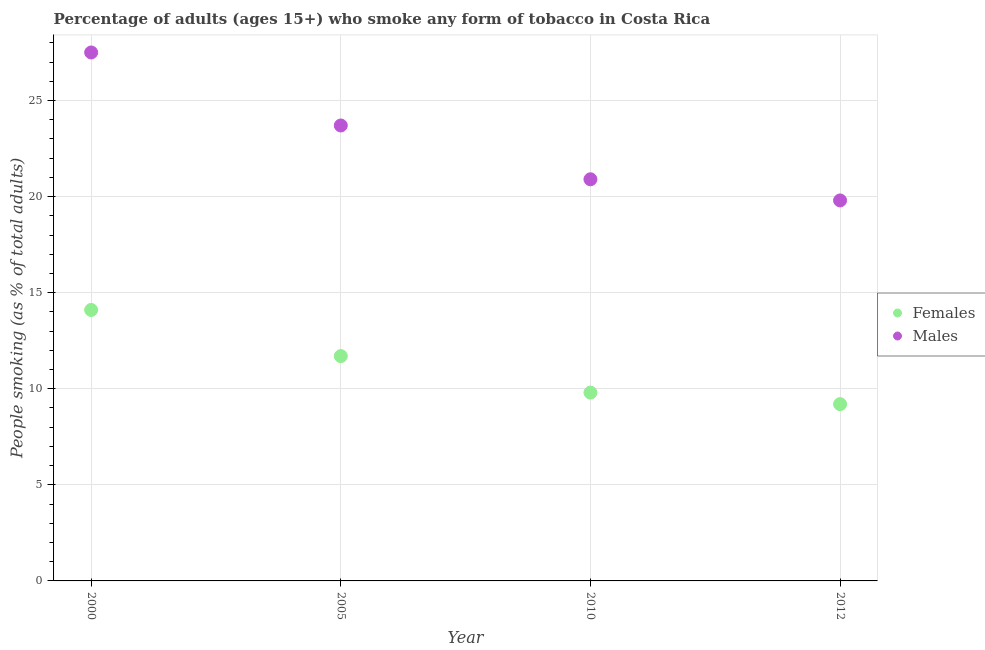How many different coloured dotlines are there?
Offer a terse response. 2. Is the number of dotlines equal to the number of legend labels?
Offer a terse response. Yes. What is the percentage of females who smoke in 2000?
Give a very brief answer. 14.1. Across all years, what is the maximum percentage of males who smoke?
Provide a short and direct response. 27.5. Across all years, what is the minimum percentage of females who smoke?
Your response must be concise. 9.2. In which year was the percentage of females who smoke maximum?
Give a very brief answer. 2000. What is the total percentage of males who smoke in the graph?
Your answer should be compact. 91.9. What is the difference between the percentage of females who smoke in 2005 and that in 2012?
Give a very brief answer. 2.5. In the year 2012, what is the difference between the percentage of males who smoke and percentage of females who smoke?
Keep it short and to the point. 10.6. What is the ratio of the percentage of females who smoke in 2005 to that in 2010?
Give a very brief answer. 1.19. What is the difference between the highest and the second highest percentage of males who smoke?
Give a very brief answer. 3.8. What is the difference between the highest and the lowest percentage of males who smoke?
Keep it short and to the point. 7.7. In how many years, is the percentage of females who smoke greater than the average percentage of females who smoke taken over all years?
Provide a succinct answer. 2. Is the sum of the percentage of males who smoke in 2010 and 2012 greater than the maximum percentage of females who smoke across all years?
Ensure brevity in your answer.  Yes. Does the percentage of females who smoke monotonically increase over the years?
Ensure brevity in your answer.  No. How many dotlines are there?
Keep it short and to the point. 2. How many years are there in the graph?
Your answer should be compact. 4. Are the values on the major ticks of Y-axis written in scientific E-notation?
Ensure brevity in your answer.  No. Does the graph contain any zero values?
Give a very brief answer. No. What is the title of the graph?
Keep it short and to the point. Percentage of adults (ages 15+) who smoke any form of tobacco in Costa Rica. What is the label or title of the X-axis?
Make the answer very short. Year. What is the label or title of the Y-axis?
Offer a very short reply. People smoking (as % of total adults). What is the People smoking (as % of total adults) of Males in 2000?
Your answer should be very brief. 27.5. What is the People smoking (as % of total adults) in Males in 2005?
Your answer should be compact. 23.7. What is the People smoking (as % of total adults) in Males in 2010?
Offer a very short reply. 20.9. What is the People smoking (as % of total adults) in Females in 2012?
Provide a succinct answer. 9.2. What is the People smoking (as % of total adults) of Males in 2012?
Keep it short and to the point. 19.8. Across all years, what is the maximum People smoking (as % of total adults) in Females?
Your response must be concise. 14.1. Across all years, what is the minimum People smoking (as % of total adults) in Females?
Your answer should be very brief. 9.2. Across all years, what is the minimum People smoking (as % of total adults) in Males?
Give a very brief answer. 19.8. What is the total People smoking (as % of total adults) in Females in the graph?
Offer a very short reply. 44.8. What is the total People smoking (as % of total adults) in Males in the graph?
Your response must be concise. 91.9. What is the difference between the People smoking (as % of total adults) in Females in 2000 and that in 2005?
Your answer should be compact. 2.4. What is the difference between the People smoking (as % of total adults) of Females in 2000 and that in 2010?
Offer a very short reply. 4.3. What is the difference between the People smoking (as % of total adults) in Males in 2000 and that in 2012?
Provide a succinct answer. 7.7. What is the difference between the People smoking (as % of total adults) of Males in 2005 and that in 2010?
Keep it short and to the point. 2.8. What is the difference between the People smoking (as % of total adults) of Females in 2005 and that in 2012?
Your response must be concise. 2.5. What is the difference between the People smoking (as % of total adults) of Females in 2010 and that in 2012?
Your response must be concise. 0.6. What is the difference between the People smoking (as % of total adults) in Males in 2010 and that in 2012?
Keep it short and to the point. 1.1. What is the difference between the People smoking (as % of total adults) of Females in 2000 and the People smoking (as % of total adults) of Males in 2005?
Give a very brief answer. -9.6. What is the difference between the People smoking (as % of total adults) of Females in 2000 and the People smoking (as % of total adults) of Males in 2010?
Give a very brief answer. -6.8. What is the difference between the People smoking (as % of total adults) in Females in 2005 and the People smoking (as % of total adults) in Males in 2010?
Your answer should be very brief. -9.2. What is the difference between the People smoking (as % of total adults) in Females in 2005 and the People smoking (as % of total adults) in Males in 2012?
Your answer should be very brief. -8.1. What is the average People smoking (as % of total adults) in Males per year?
Your answer should be compact. 22.98. In the year 2000, what is the difference between the People smoking (as % of total adults) in Females and People smoking (as % of total adults) in Males?
Keep it short and to the point. -13.4. In the year 2005, what is the difference between the People smoking (as % of total adults) in Females and People smoking (as % of total adults) in Males?
Offer a terse response. -12. In the year 2010, what is the difference between the People smoking (as % of total adults) in Females and People smoking (as % of total adults) in Males?
Your answer should be very brief. -11.1. In the year 2012, what is the difference between the People smoking (as % of total adults) of Females and People smoking (as % of total adults) of Males?
Offer a very short reply. -10.6. What is the ratio of the People smoking (as % of total adults) in Females in 2000 to that in 2005?
Your response must be concise. 1.21. What is the ratio of the People smoking (as % of total adults) of Males in 2000 to that in 2005?
Give a very brief answer. 1.16. What is the ratio of the People smoking (as % of total adults) of Females in 2000 to that in 2010?
Keep it short and to the point. 1.44. What is the ratio of the People smoking (as % of total adults) of Males in 2000 to that in 2010?
Offer a very short reply. 1.32. What is the ratio of the People smoking (as % of total adults) of Females in 2000 to that in 2012?
Your response must be concise. 1.53. What is the ratio of the People smoking (as % of total adults) in Males in 2000 to that in 2012?
Provide a succinct answer. 1.39. What is the ratio of the People smoking (as % of total adults) in Females in 2005 to that in 2010?
Your response must be concise. 1.19. What is the ratio of the People smoking (as % of total adults) of Males in 2005 to that in 2010?
Provide a short and direct response. 1.13. What is the ratio of the People smoking (as % of total adults) in Females in 2005 to that in 2012?
Ensure brevity in your answer.  1.27. What is the ratio of the People smoking (as % of total adults) in Males in 2005 to that in 2012?
Your response must be concise. 1.2. What is the ratio of the People smoking (as % of total adults) of Females in 2010 to that in 2012?
Provide a succinct answer. 1.07. What is the ratio of the People smoking (as % of total adults) of Males in 2010 to that in 2012?
Offer a very short reply. 1.06. What is the difference between the highest and the second highest People smoking (as % of total adults) in Females?
Your response must be concise. 2.4. 